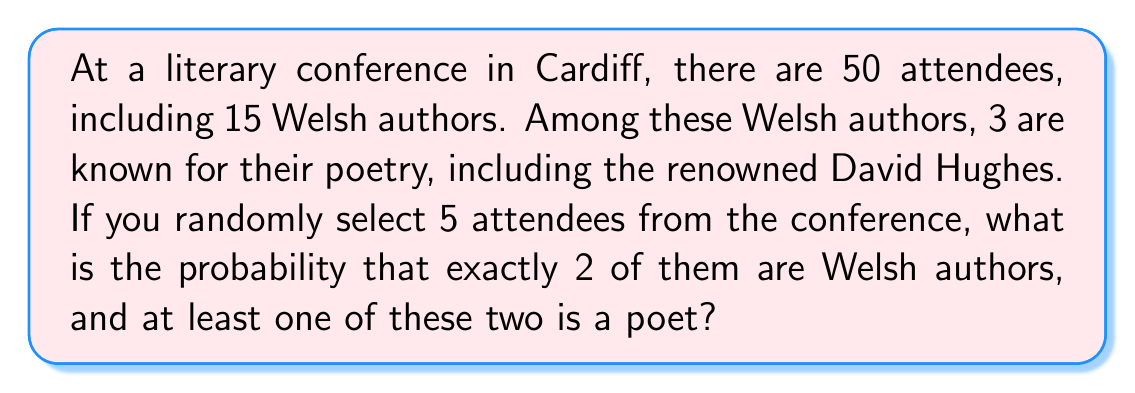Solve this math problem. Let's approach this step-by-step using the concepts of combinatorics and probability:

1) First, we need to calculate the probability of selecting exactly 2 Welsh authors out of 5 attendees:

   $P(\text{2 Welsh authors}) = \frac{\binom{15}{2} \binom{35}{3}}{\binom{50}{5}}$

   Where $\binom{n}{k}$ represents the binomial coefficient.

2) Now, we need to consider the probability that at least one of these two Welsh authors is a poet. There are two favorable scenarios:
   a) 1 poet and 1 non-poet Welsh author
   b) 2 poet Welsh authors

3) For scenario a):
   $P(\text{1 poet, 1 non-poet}) = \frac{\binom{3}{1} \binom{12}{1}}{\binom{15}{2}}$

4) For scenario b):
   $P(\text{2 poets}) = \frac{\binom{3}{2}}{\binom{15}{2}}$

5) The total probability of at least one poet among the two Welsh authors is:
   $P(\text{at least 1 poet}) = P(\text{1 poet, 1 non-poet}) + P(\text{2 poets})$

6) Therefore, the final probability is:

   $P(\text{2 Welsh authors}) \times P(\text{at least 1 poet})$

   $= \frac{\binom{15}{2} \binom{35}{3}}{\binom{50}{5}} \times (\frac{\binom{3}{1} \binom{12}{1}}{\binom{15}{2}} + \frac{\binom{3}{2}}{\binom{15}{2}})$

7) Calculating this:
   $= \frac{105 \times 6545}{2118760} \times (\frac{3 \times 12}{105} + \frac{3}{105})$
   $= 0.0324 \times 0.4286$
   $= 0.0139$
Answer: The probability is approximately 0.0139 or 1.39%. 